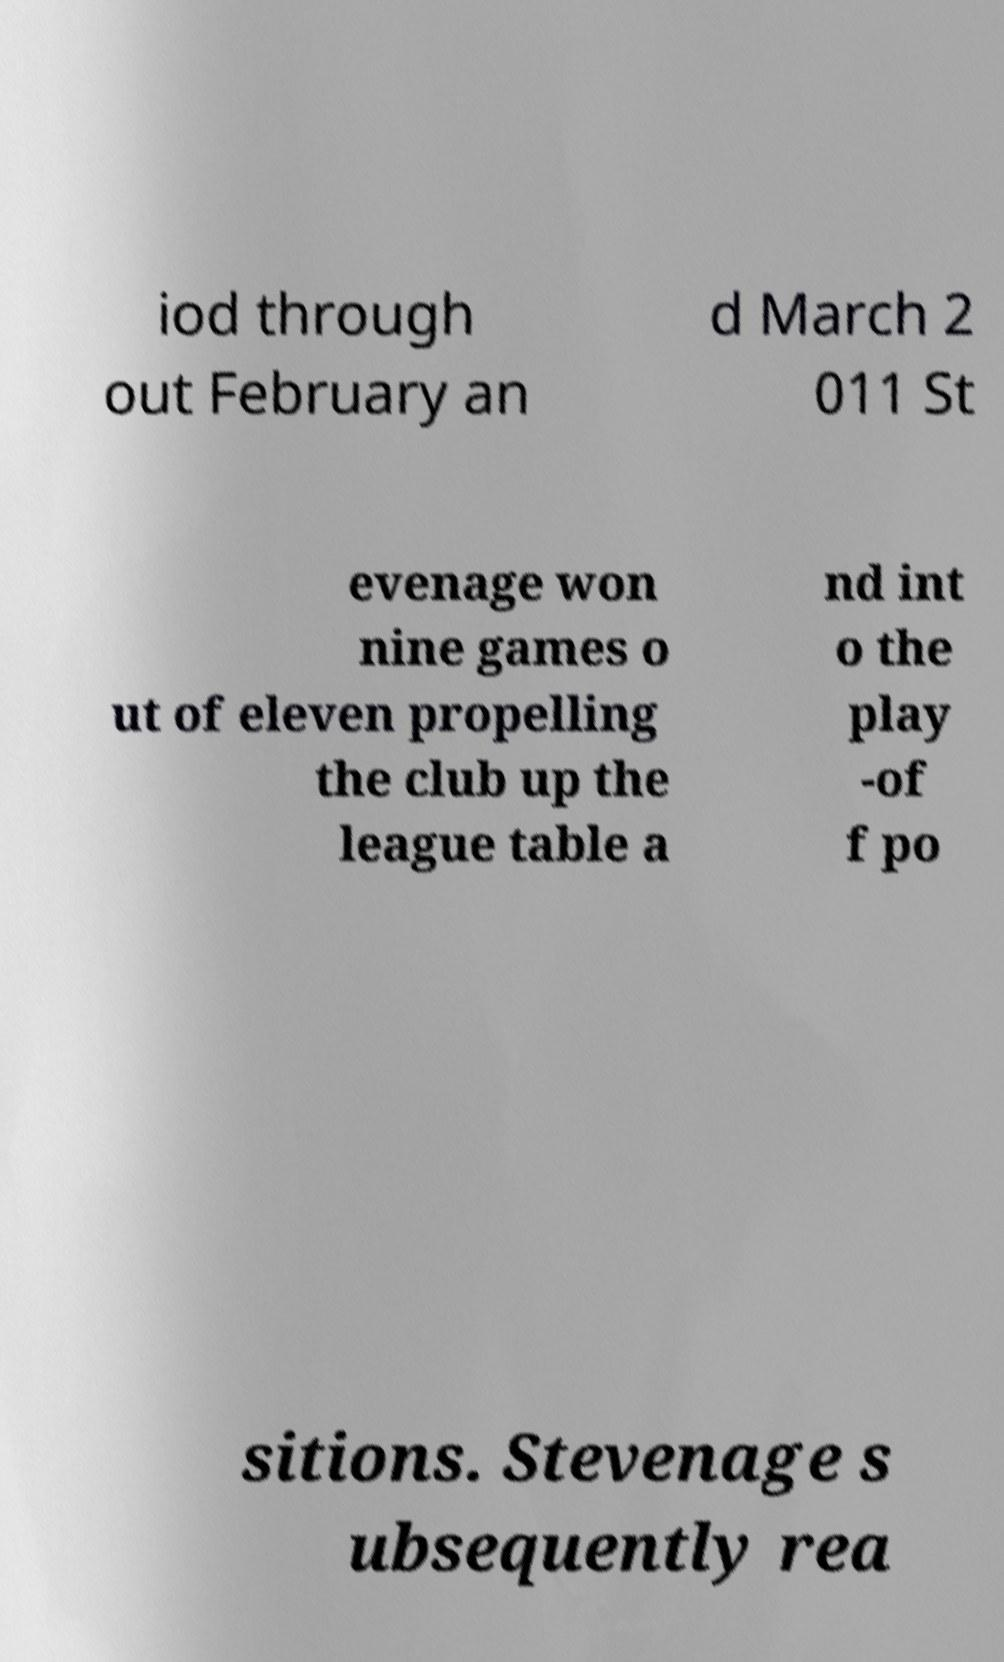Can you accurately transcribe the text from the provided image for me? iod through out February an d March 2 011 St evenage won nine games o ut of eleven propelling the club up the league table a nd int o the play -of f po sitions. Stevenage s ubsequently rea 